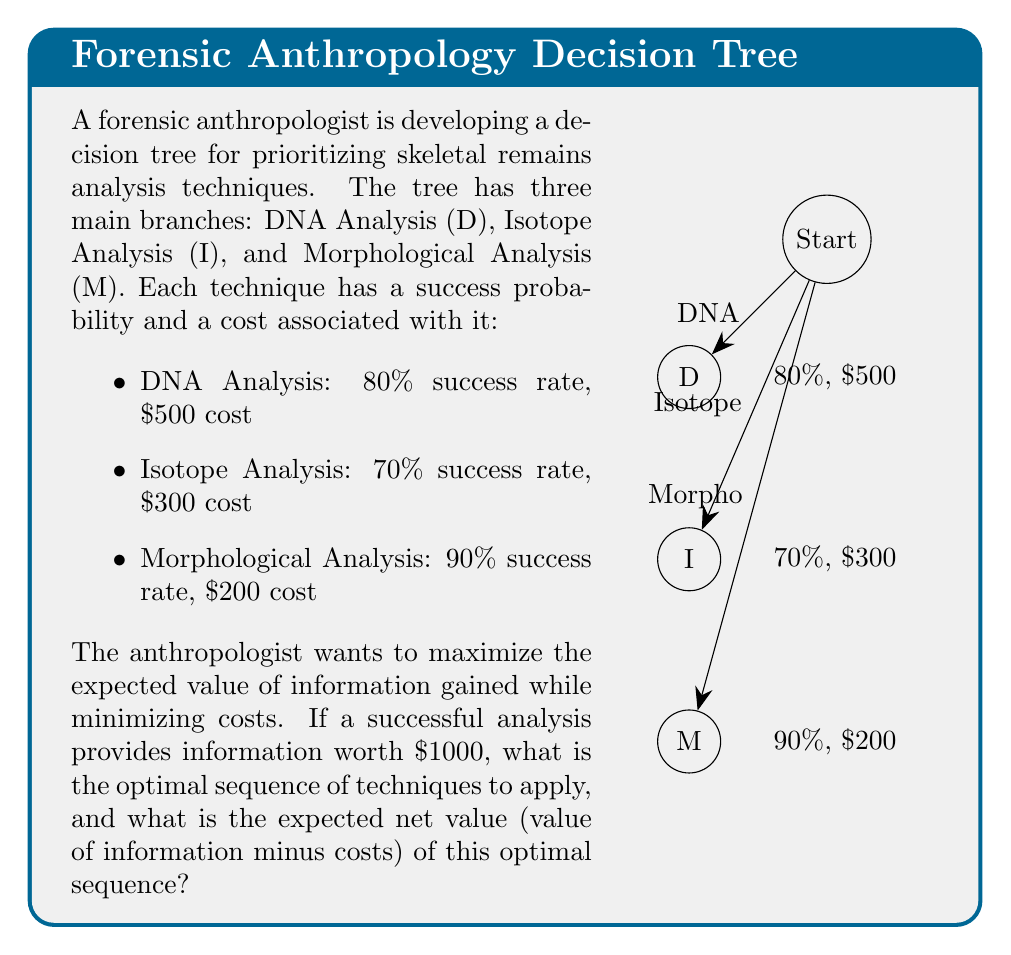Provide a solution to this math problem. To solve this problem, we need to calculate the expected value for each technique and then determine the optimal sequence. Let's approach this step-by-step:

1) Calculate the expected value (EV) for each technique:

   EV = (Success Probability × Value of Information) - Cost

   DNA: $EV_D = (0.80 \times \$1000) - \$500 = \$300$
   Isotope: $EV_I = (0.70 \times \$1000) - \$300 = \$400$
   Morphological: $EV_M = (0.90 \times \$1000) - \$200 = \$700$

2) Rank the techniques based on their expected values:
   Morphological (M) > Isotope (I) > DNA (D)

3) To determine the optimal sequence, we start with the technique with the highest EV (M). If it fails, we move to the next highest (I), and if that fails, we use the last technique (D).

4) Calculate the overall expected net value:

   $EV_{total} = EV_M + (1-0.90) \times EV_I + (1-0.90) \times (1-0.70) \times EV_D$

   $EV_{total} = 700 + 0.10 \times 400 + 0.10 \times 0.30 \times 300$

   $EV_{total} = 700 + 40 + 9 = \$749$

Thus, the optimal sequence is Morphological (M) → Isotope (I) → DNA (D), with an expected net value of $749.
Answer: Sequence: M → I → D; Expected net value: $749 